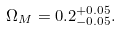Convert formula to latex. <formula><loc_0><loc_0><loc_500><loc_500>\Omega _ { M } = 0 . 2 ^ { + 0 . 0 5 } _ { - 0 . 0 5 } .</formula> 